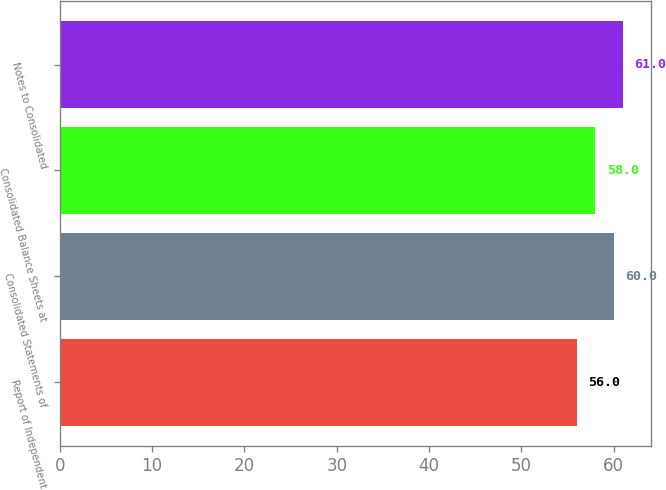Convert chart to OTSL. <chart><loc_0><loc_0><loc_500><loc_500><bar_chart><fcel>Report of Independent<fcel>Consolidated Statements of<fcel>Consolidated Balance Sheets at<fcel>Notes to Consolidated<nl><fcel>56<fcel>60<fcel>58<fcel>61<nl></chart> 